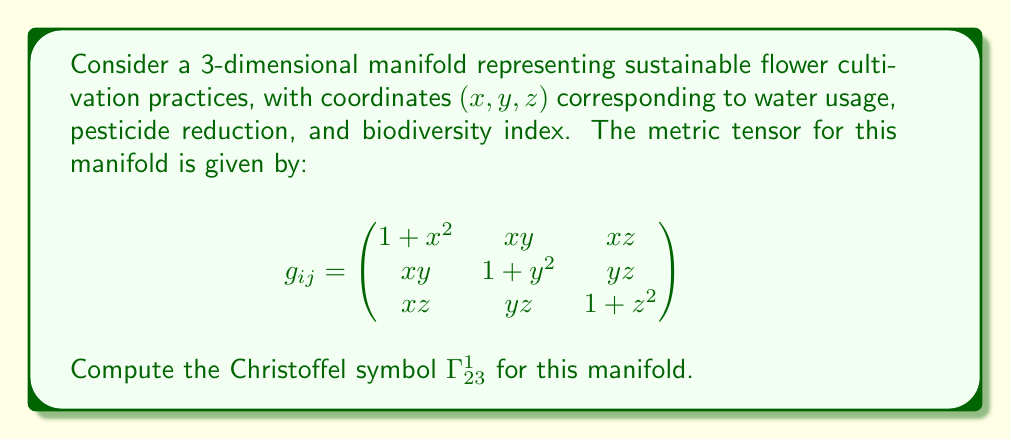Can you answer this question? To compute the Christoffel symbol $\Gamma^1_{23}$, we'll use the formula:

$$\Gamma^k_{ij} = \frac{1}{2}g^{kl}\left(\frac{\partial g_{jl}}{\partial x^i} + \frac{\partial g_{il}}{\partial x^j} - \frac{\partial g_{ij}}{\partial x^l}\right)$$

Steps:
1) First, we need to find the inverse metric tensor $g^{ij}$. However, for $\Gamma^1_{23}$, we only need the first row of $g^{ij}$.

2) The determinant of $g_{ij}$ is complex, so we'll use the cofactor method to find $g^{11}, g^{12},$ and $g^{13}$:

   $$g^{11} = \frac{(1+y^2)(1+z^2)-y^2z^2}{det(g_{ij})}$$
   $$g^{12} = \frac{-xy(1+z^2)+yz\cdot xz}{det(g_{ij})}$$
   $$g^{13} = \frac{-xz(1+y^2)+xy\cdot yz}{det(g_{ij})}$$

3) Now, we calculate the partial derivatives:

   $$\frac{\partial g_{23}}{\partial x} = 0$$
   $$\frac{\partial g_{13}}{\partial y} = z$$
   $$\frac{\partial g_{12}}{\partial z} = 0$$

4) Substituting into the Christoffel symbol formula:

   $$\Gamma^1_{23} = \frac{1}{2}(g^{11} \cdot 0 + g^{12} \cdot z + g^{13} \cdot 0)$$

5) Simplifying:

   $$\Gamma^1_{23} = \frac{1}{2}g^{12}z = \frac{-xy(1+z^2)+yz\cdot xz}{2\det(g_{ij})}z$$

6) Further simplification:

   $$\Gamma^1_{23} = \frac{-xyz(1+z^2)+y z^2\cdot x}{2\det(g_{ij})} = \frac{-xyz}{2\det(g_{ij})}$$
Answer: $$\Gamma^1_{23} = \frac{-xyz}{2\det(g_{ij})}$$ 